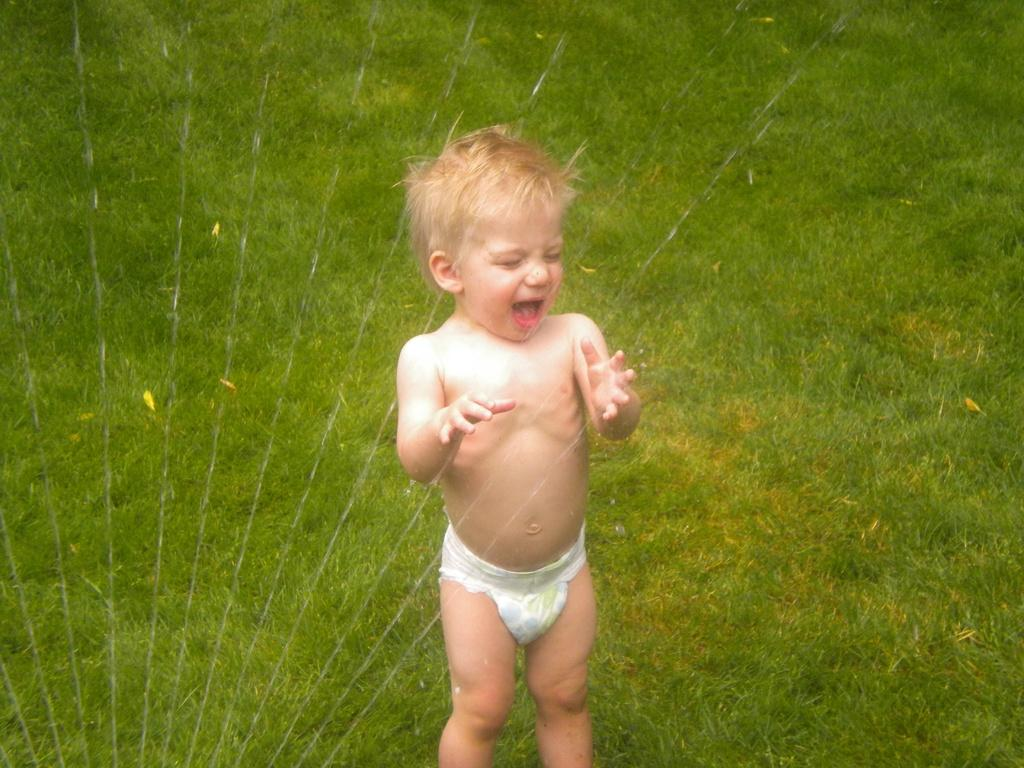What is the main subject of the image? The main subject of the image is a kid. Where is the kid standing in the image? The kid is standing on the ground. What can be seen in the background of the image? There is grass in the background of the image. What things does the kid select in the image? There is no indication in the image that the kid is selecting any things. 